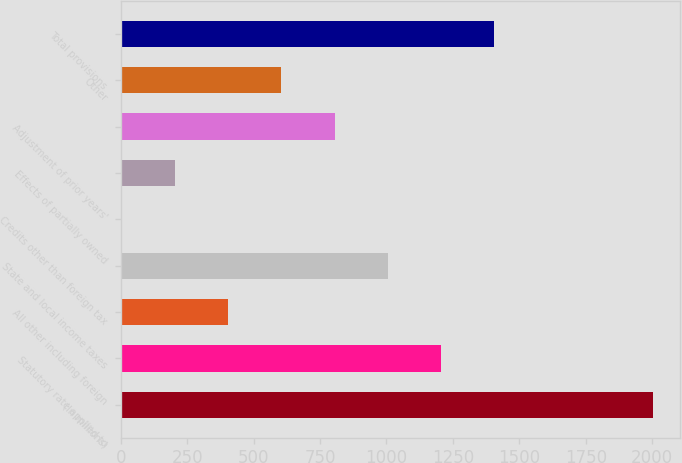Convert chart to OTSL. <chart><loc_0><loc_0><loc_500><loc_500><bar_chart><fcel>(In millions)<fcel>Statutory rate applied to<fcel>All other including foreign<fcel>State and local income taxes<fcel>Credits other than foreign tax<fcel>Effects of partially owned<fcel>Adjustment of prior years'<fcel>Other<fcel>Total provisions<nl><fcel>2003<fcel>1204.2<fcel>405.4<fcel>1004.5<fcel>6<fcel>205.7<fcel>804.8<fcel>605.1<fcel>1403.9<nl></chart> 